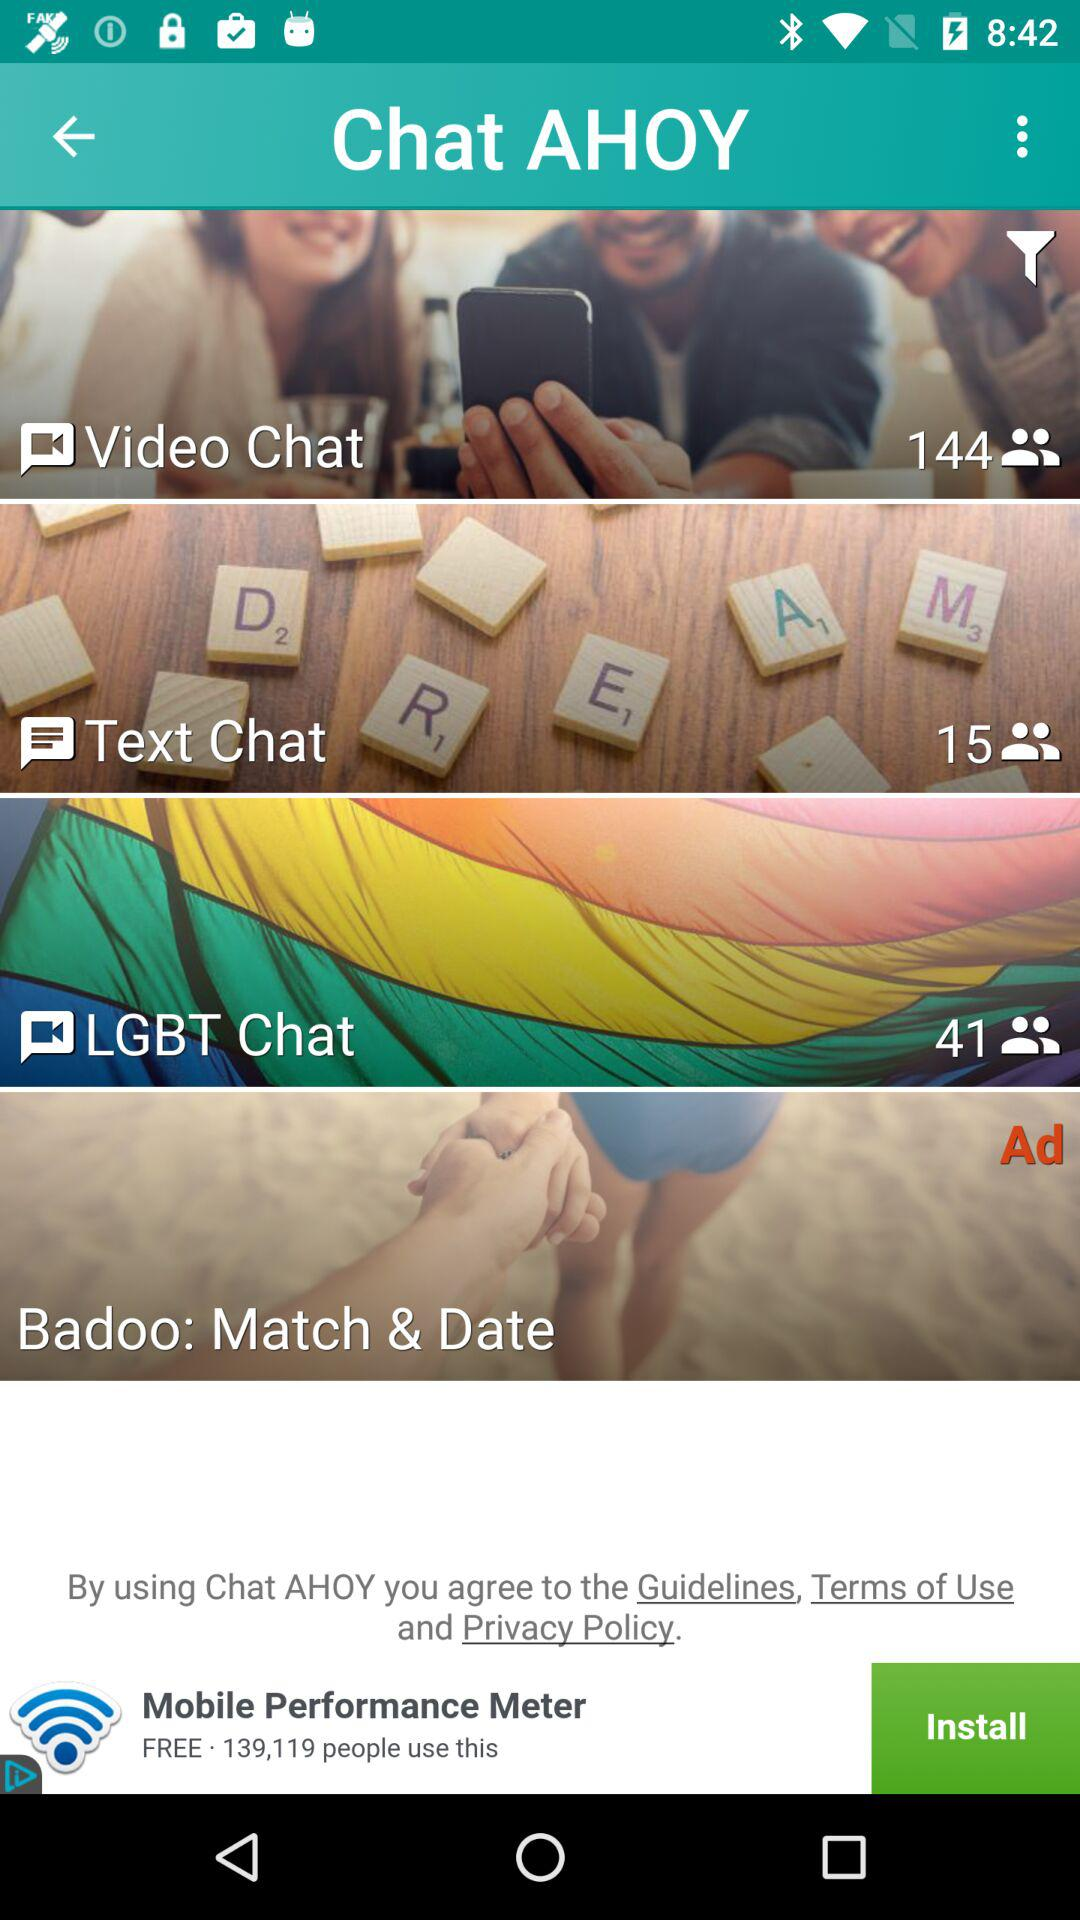What is the number of users in "Video Chat"? The number of users is 144. 